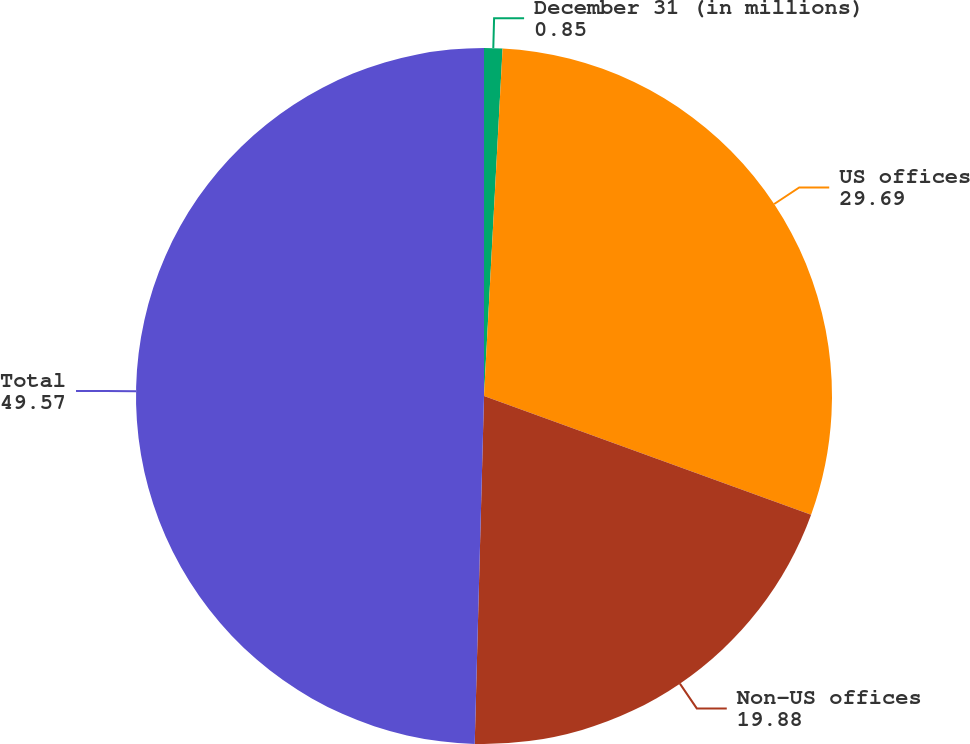<chart> <loc_0><loc_0><loc_500><loc_500><pie_chart><fcel>December 31 (in millions)<fcel>US offices<fcel>Non-US offices<fcel>Total<nl><fcel>0.85%<fcel>29.69%<fcel>19.88%<fcel>49.57%<nl></chart> 